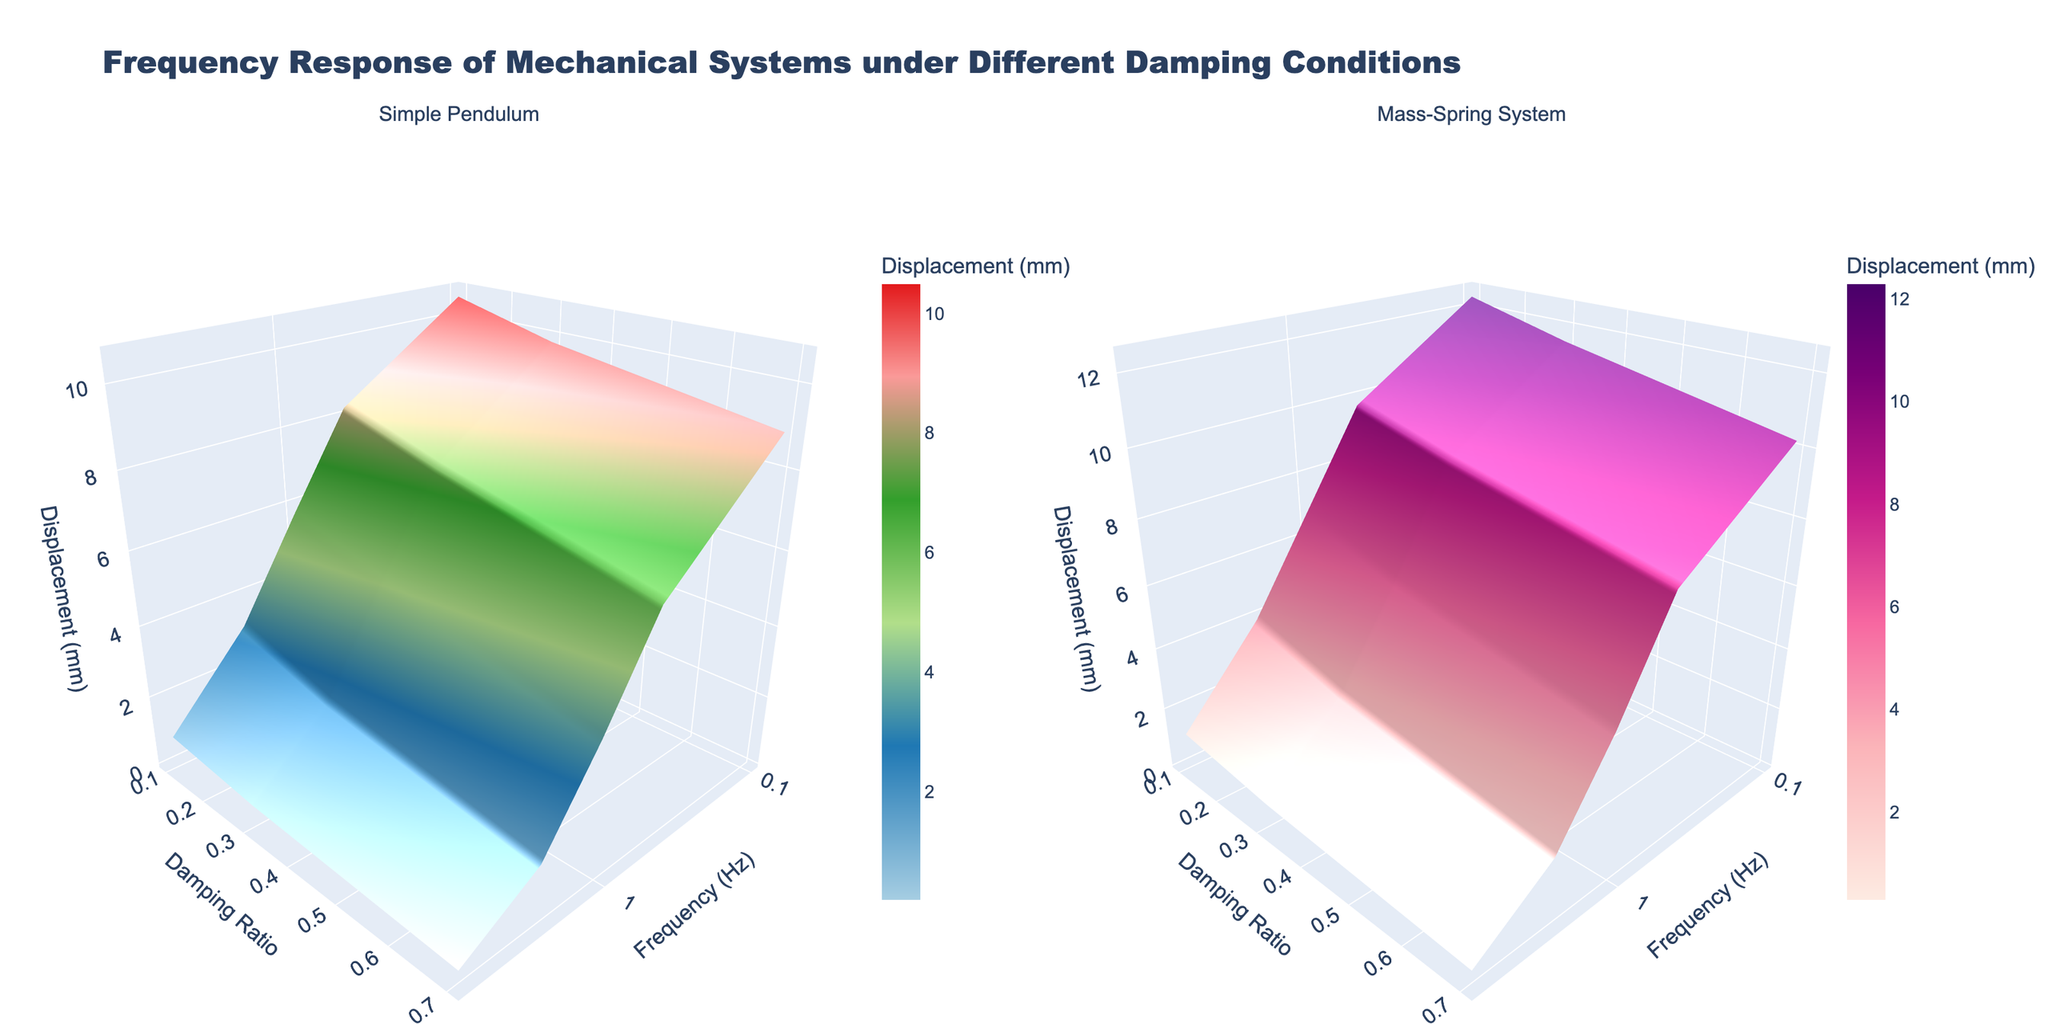What is the title of the figure? The title is clearly written at the top of the figure.
Answer: Frequency Response of Mechanical Systems under Different Damping Conditions What are the axis titles for the subplot showing the Simple Pendulum? The axis titles are indicated under each subplot. For the Simple Pendulum, the x-axis is "Frequency (Hz)", the y-axis is "Damping Ratio", and the z-axis is "Displacement (mm)".
Answer: Frequency (Hz), Damping Ratio, Displacement (mm) How does the displacement change with increasing frequency for a Simple Pendulum with a damping ratio of 0.1? Follow the curve on the Simple Pendulum subplot where the damping ratio is 0.1. Observe the displacement values as the frequency increases.
Answer: It decreases Which system has a higher initial displacement at a frequency of 0.1 Hz, Simple Pendulum or Mass-Spring System? Identify the displacement at 0.1 Hz for both systems by examining the corresponding points on both subplots.
Answer: Mass-Spring System What is the displacement value for the Mass-Spring System at a damping ratio of 0.7 and a frequency of 5.0 Hz? Locate the interaction point at a damping ratio of 0.7 and a frequency of 5.0 Hz on the Mass-Spring System subplot. Read off the displacement value from the color scale or contour labels.
Answer: 0.3 mm How does the effect of damping ratio on displacement compare between the two systems at 1.0 Hz? Compare the displacement values at 1.0 Hz across different damping ratios (0.1, 0.3, 0.7) for both systems by examining the two subplots.
Answer: The displacement decreases more rapidly for the Simple Pendulum For which system and at what frequency does the displacement fall below 1 mm at a damping ratio of 0.3? Look for the point at which the displacement drops below 1 mm at a damping ratio of 0.3 on both subplots. Check the corresponding frequency values.
Answer: Simple Pendulum, at 2.0 Hz What is the difference in displacement between the two systems at a frequency of 2.0 Hz with a damping ratio of 0.1? Locate the displacement values at a frequency of 2.0 Hz and a damping ratio of 0.1 for both systems. Subtract the Simple Pendulum displacement from the Mass-Spring System displacement.
Answer: 0.8 mm How does the displacement change with frequency in the Mass-Spring System for all damping ratios given? Check the trend of displacement values across all three damping ratios in the Mass-Spring System subplot, noting how these values vary with frequency.
Answer: Displacement decreases Which system exhibits a wider range of displacement values overall? Compare the range of displacement values (highest to lowest) visually on both subplots by observing the color gradients or height differences of the surfaces.
Answer: Simple Pendulum 